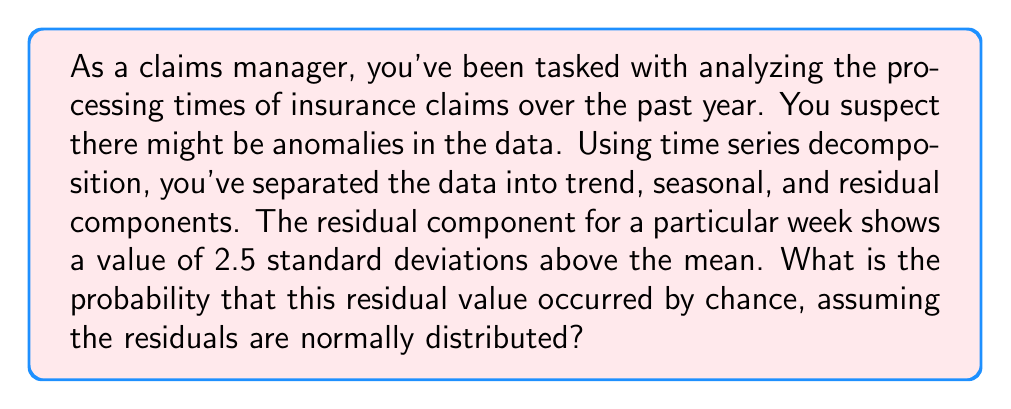Solve this math problem. To solve this problem, we need to follow these steps:

1) First, recall that in a normal distribution, approximately 68% of the data falls within 1 standard deviation of the mean, 95% within 2 standard deviations, and 99.7% within 3 standard deviations.

2) We're given that the residual value is 2.5 standard deviations above the mean. This means we need to find the probability of a value being at least 2.5 standard deviations above the mean.

3) In statistical terms, we're looking for P(Z ≥ 2.5), where Z is the standard normal variable.

4) To find this probability, we need to use a standard normal table or a statistical software. However, most tables give the area to the left of a Z-score.

5) The area we're looking for is the area to the right of Z = 2.5. We can find this by subtracting the area to the left of Z = 2.5 from 1.

6) Using a standard normal table or calculator, we find that:

   P(Z < 2.5) ≈ 0.9938

7) Therefore, P(Z ≥ 2.5) = 1 - P(Z < 2.5) = 1 - 0.9938 = 0.0062

8) This means there's approximately a 0.62% chance of observing a value this extreme or more extreme by random chance.

This low probability suggests that this particular week's processing time is indeed anomalous and warrants further investigation.
Answer: The probability is approximately 0.0062 or 0.62%. 